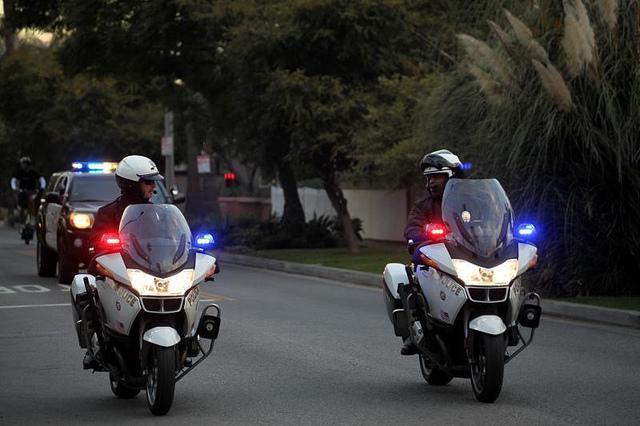How many people are visible?
Give a very brief answer. 2. How many motorcycles are in the picture?
Give a very brief answer. 2. How many birds on the beach are the right side of the surfers?
Give a very brief answer. 0. 